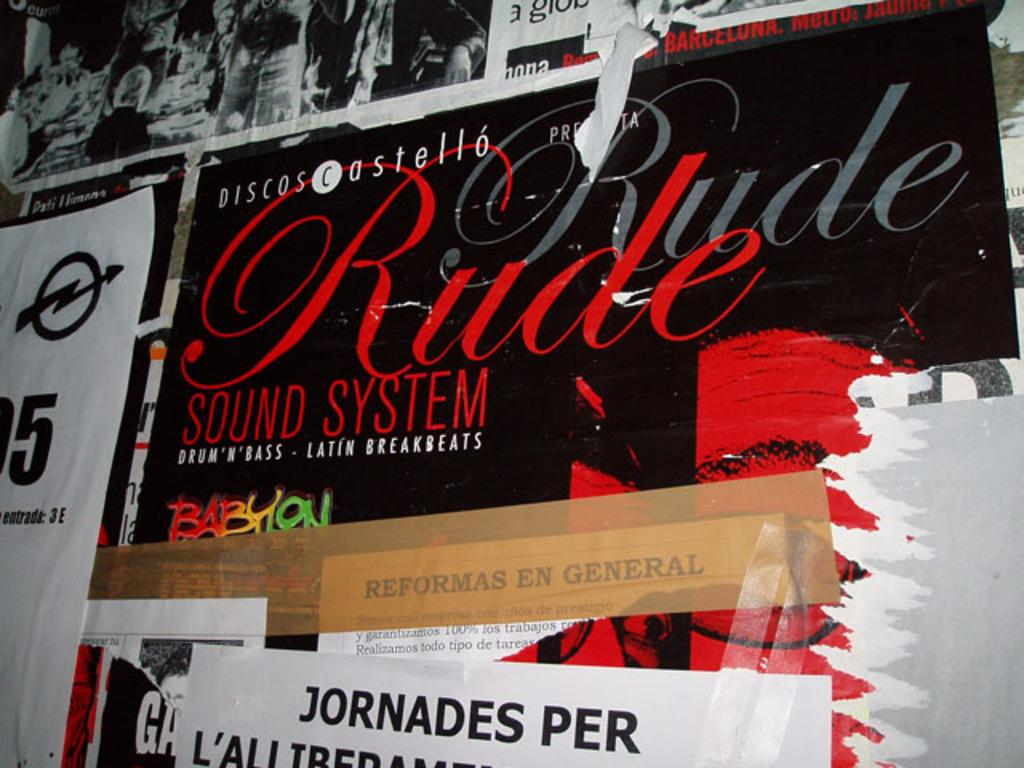<image>
Offer a succinct explanation of the picture presented. A cardboard box from a Rude Sound System. 